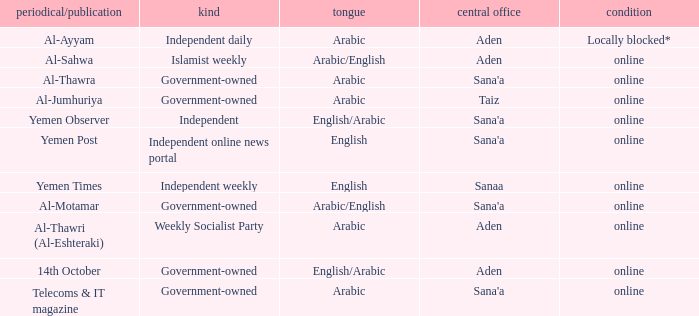What is Headquarter, when Language is English, and when Type is Independent Online News Portal? Sana'a. 